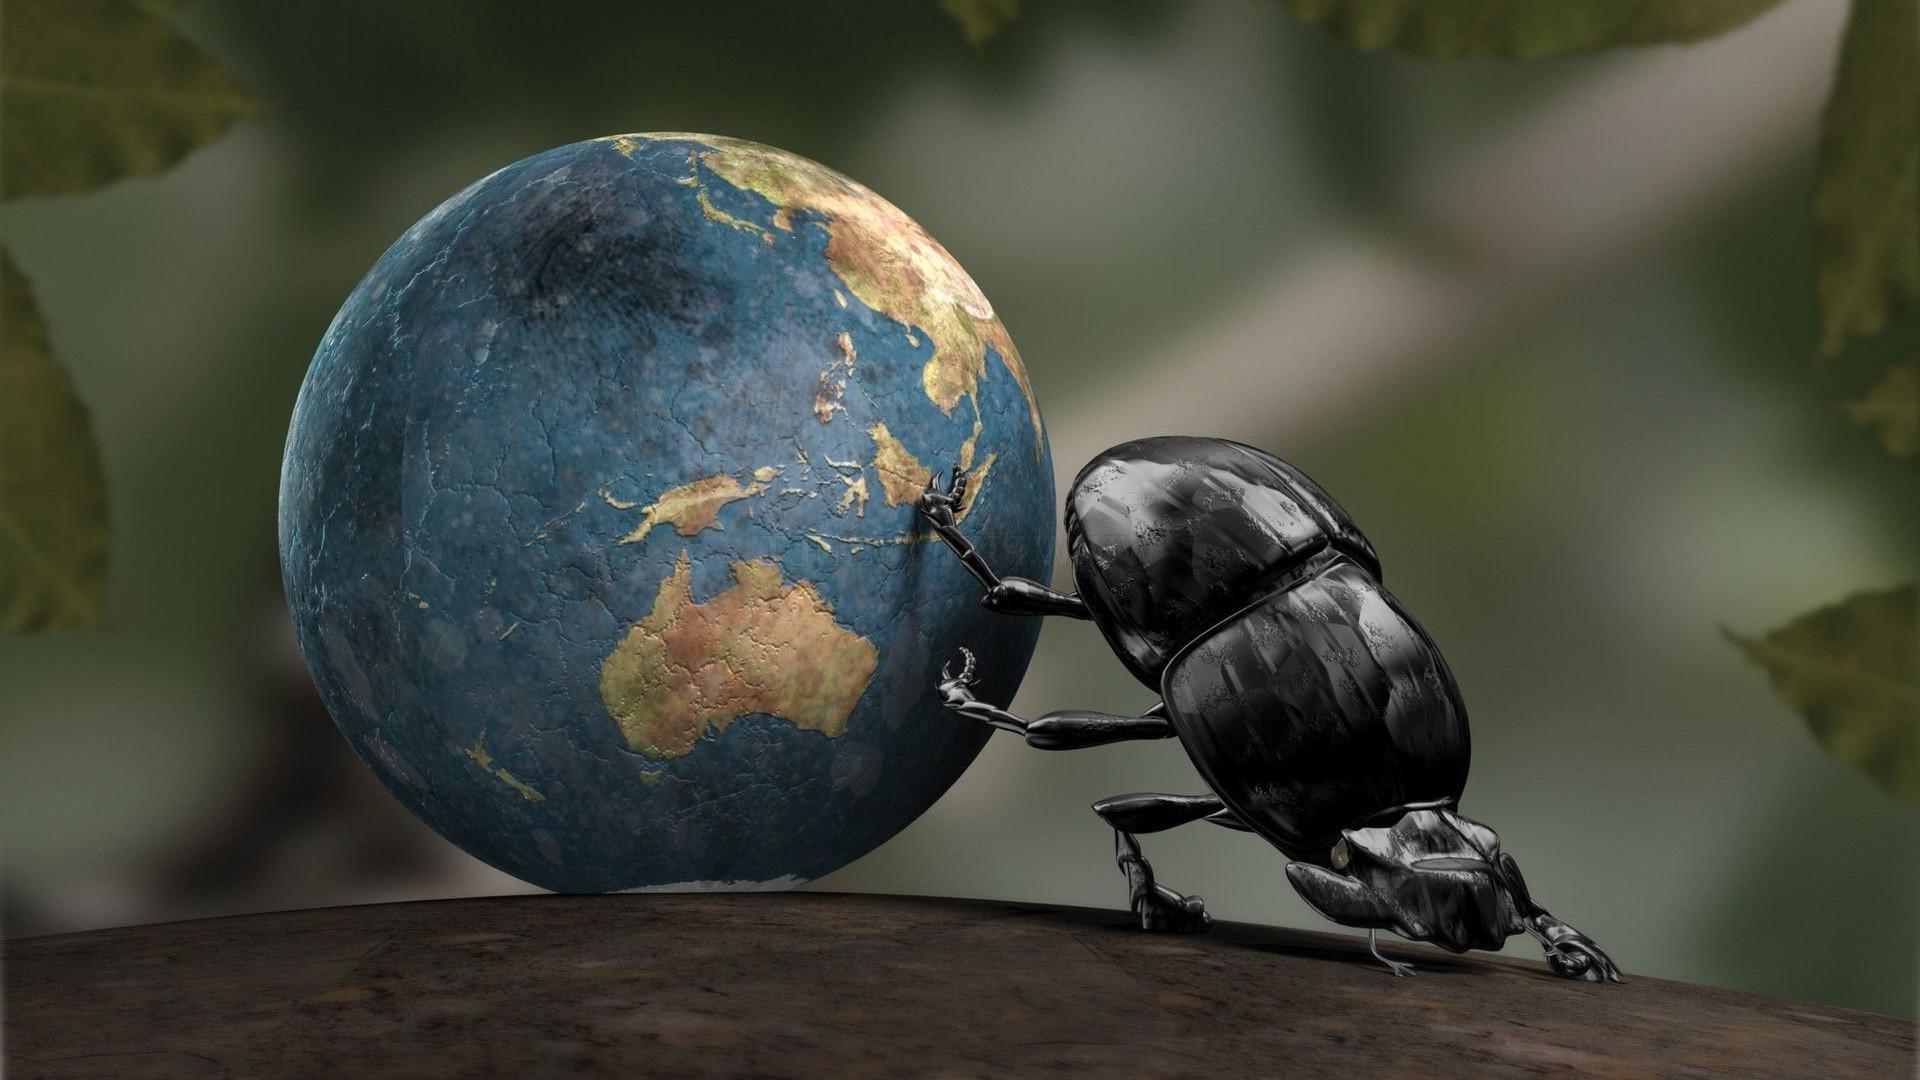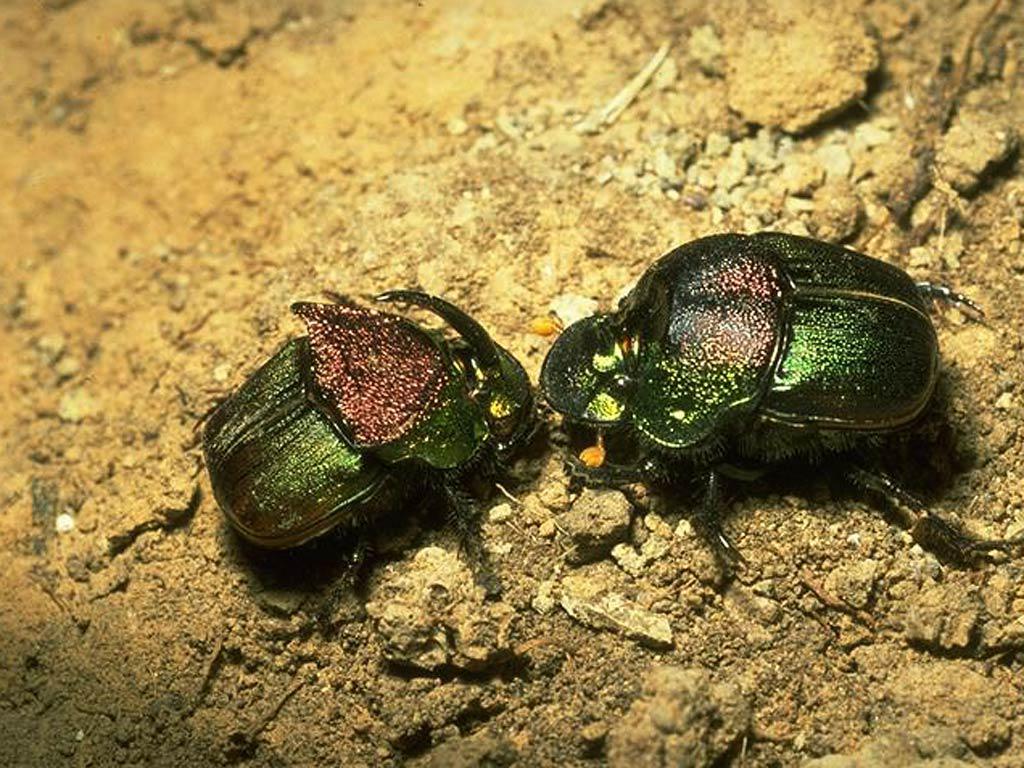The first image is the image on the left, the second image is the image on the right. Analyze the images presented: Is the assertion "There are two beetles in the right image." valid? Answer yes or no. Yes. The first image is the image on the left, the second image is the image on the right. Analyze the images presented: Is the assertion "Each image includes at least one beetle in contact with one brown ball." valid? Answer yes or no. No. 